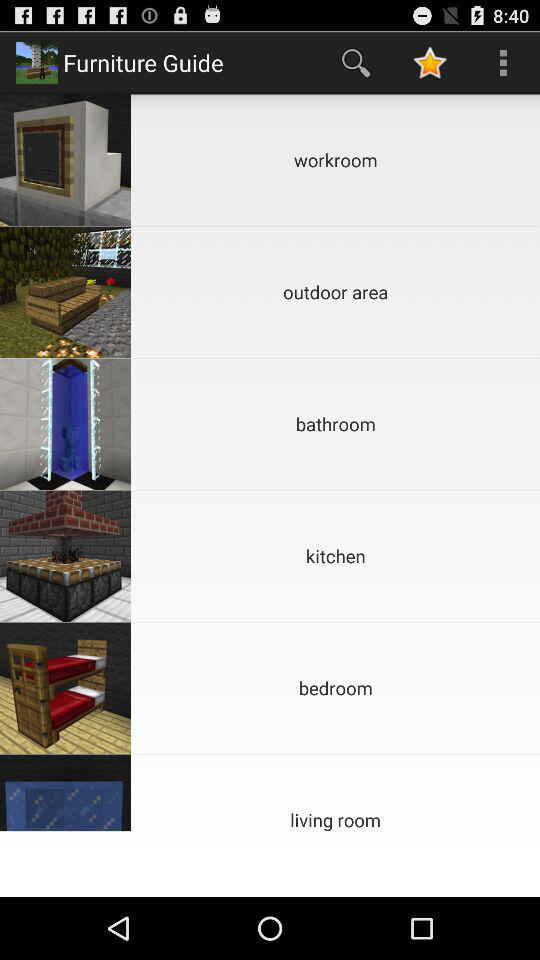How many rooms are there in total?
Answer the question using a single word or phrase. 6 